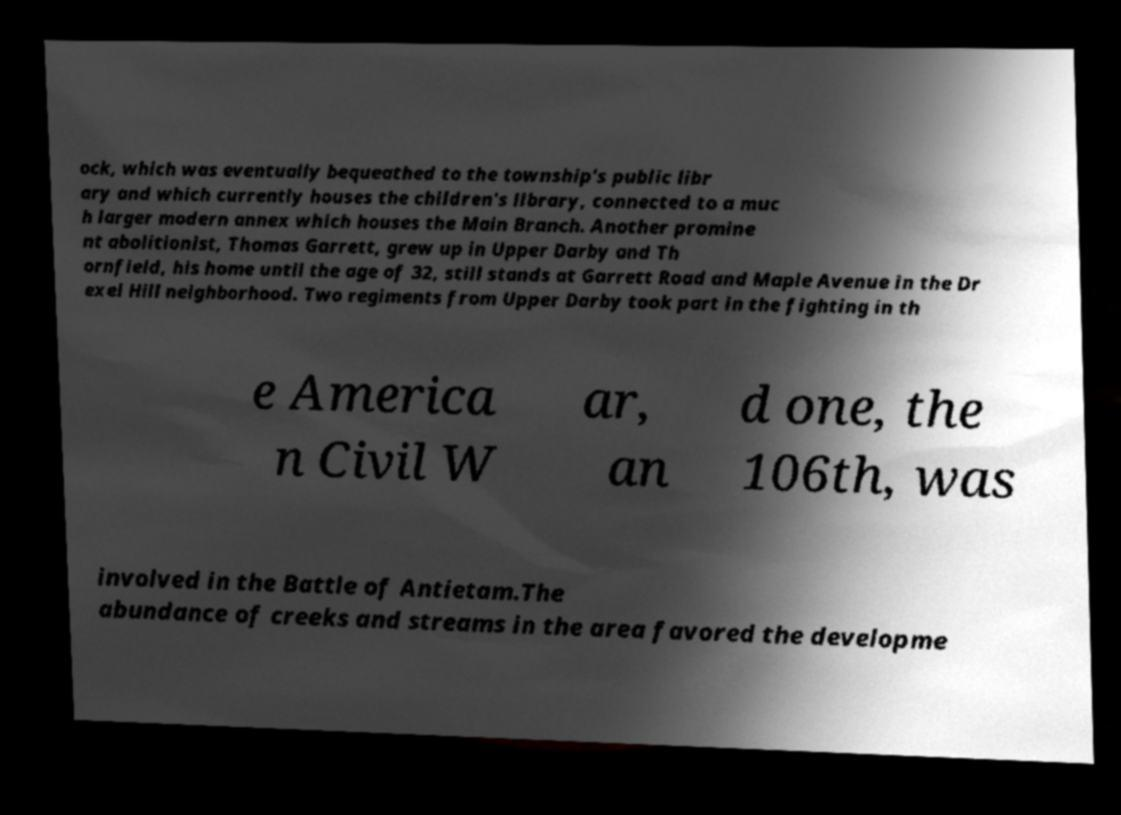For documentation purposes, I need the text within this image transcribed. Could you provide that? ock, which was eventually bequeathed to the township's public libr ary and which currently houses the children's library, connected to a muc h larger modern annex which houses the Main Branch. Another promine nt abolitionist, Thomas Garrett, grew up in Upper Darby and Th ornfield, his home until the age of 32, still stands at Garrett Road and Maple Avenue in the Dr exel Hill neighborhood. Two regiments from Upper Darby took part in the fighting in th e America n Civil W ar, an d one, the 106th, was involved in the Battle of Antietam.The abundance of creeks and streams in the area favored the developme 